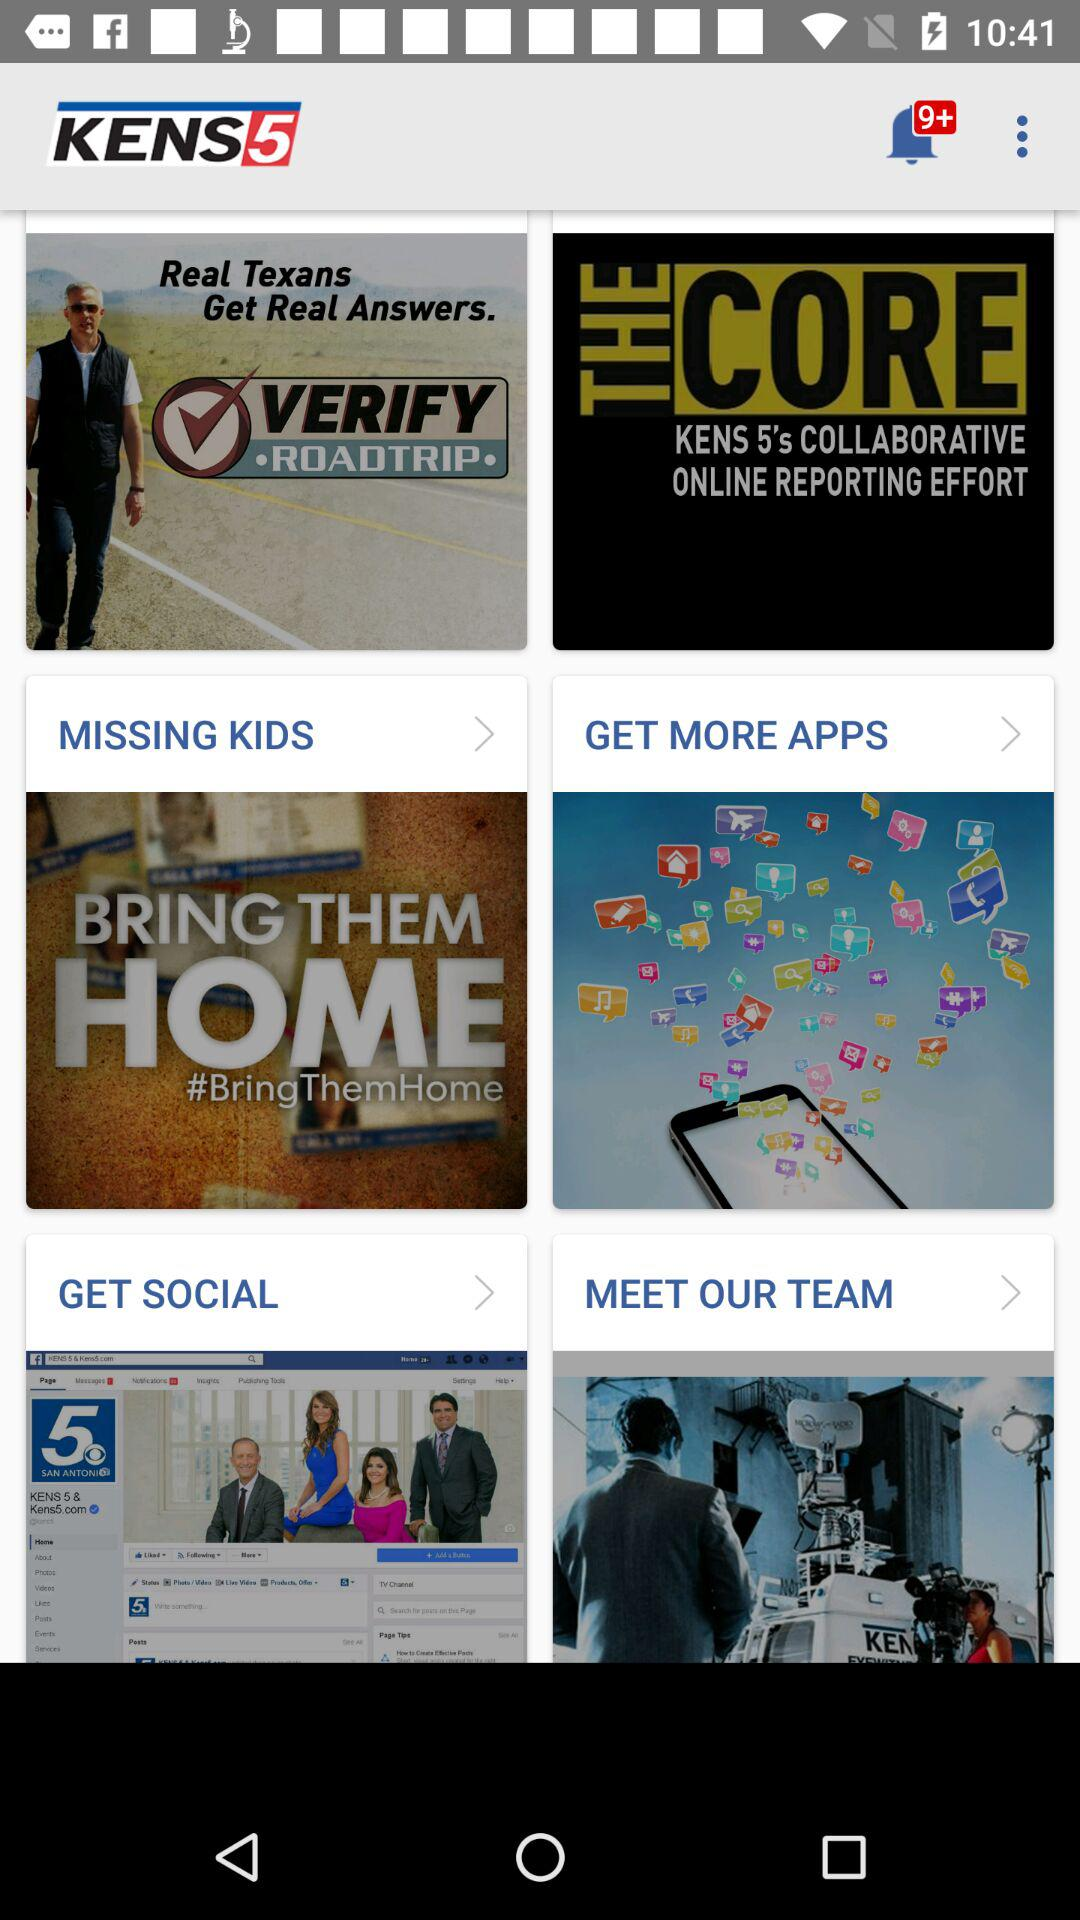What is the name of the application? The name of the application is "KENS5". 